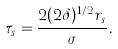<formula> <loc_0><loc_0><loc_500><loc_500>\tau _ { s } = \frac { 2 ( 2 \delta ) ^ { 1 / 2 } r _ { s } } { \sigma } .</formula> 